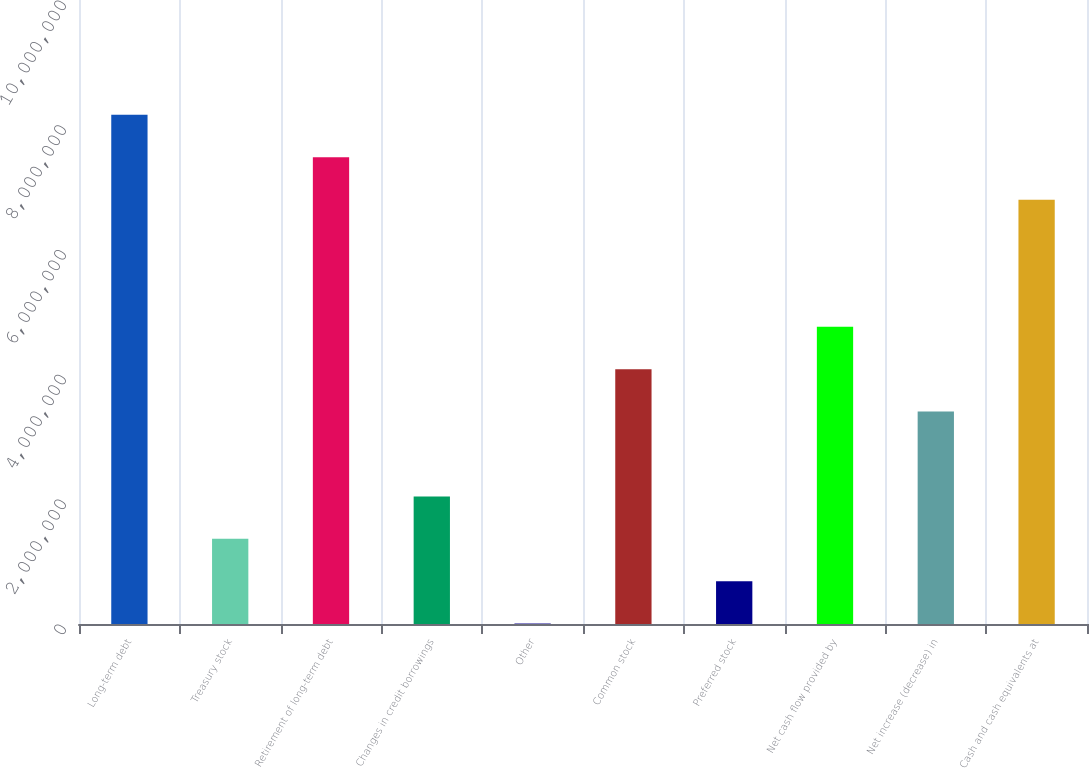Convert chart. <chart><loc_0><loc_0><loc_500><loc_500><bar_chart><fcel>Long-term debt<fcel>Treasury stock<fcel>Retirement of long-term debt<fcel>Changes in credit borrowings<fcel>Other<fcel>Common stock<fcel>Preferred stock<fcel>Net cash flow provided by<fcel>Net increase (decrease) in<fcel>Cash and cash equivalents at<nl><fcel>8.1593e+06<fcel>1.36561e+06<fcel>7.47993e+06<fcel>2.04498e+06<fcel>6872<fcel>4.08308e+06<fcel>686241<fcel>4.76245e+06<fcel>3.40372e+06<fcel>6.80056e+06<nl></chart> 